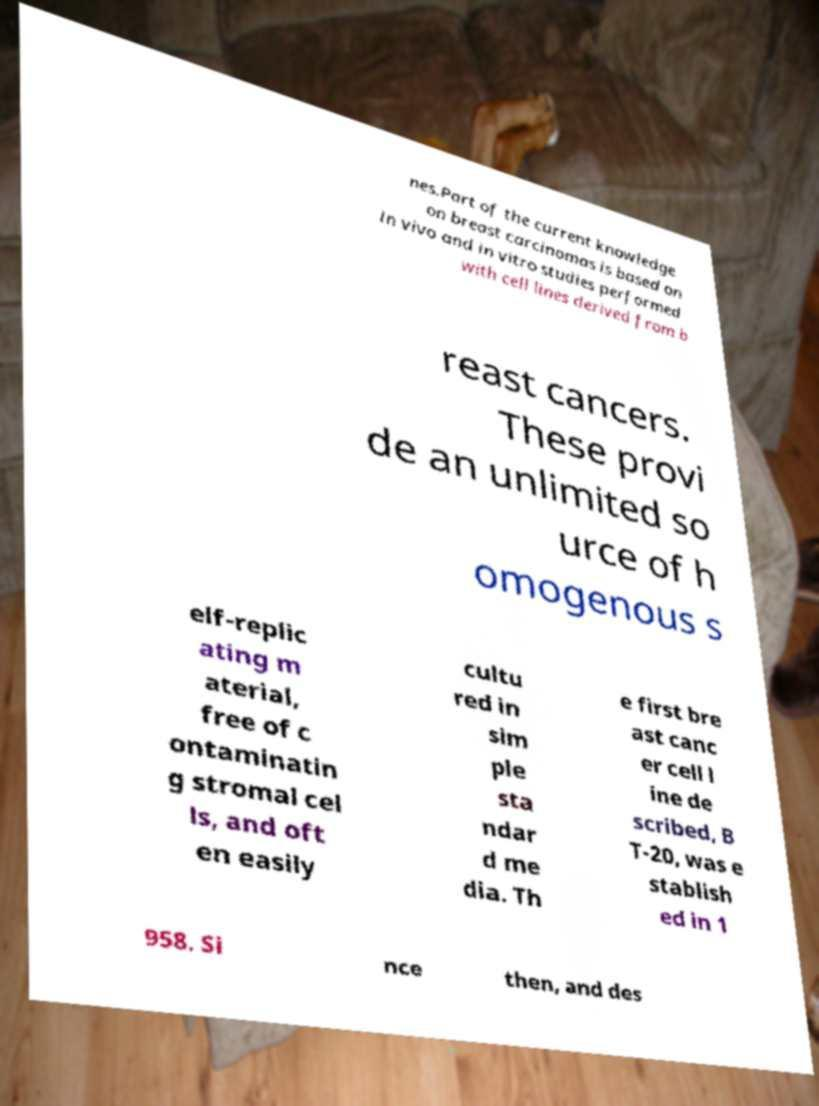Can you read and provide the text displayed in the image?This photo seems to have some interesting text. Can you extract and type it out for me? nes.Part of the current knowledge on breast carcinomas is based on in vivo and in vitro studies performed with cell lines derived from b reast cancers. These provi de an unlimited so urce of h omogenous s elf-replic ating m aterial, free of c ontaminatin g stromal cel ls, and oft en easily cultu red in sim ple sta ndar d me dia. Th e first bre ast canc er cell l ine de scribed, B T-20, was e stablish ed in 1 958. Si nce then, and des 